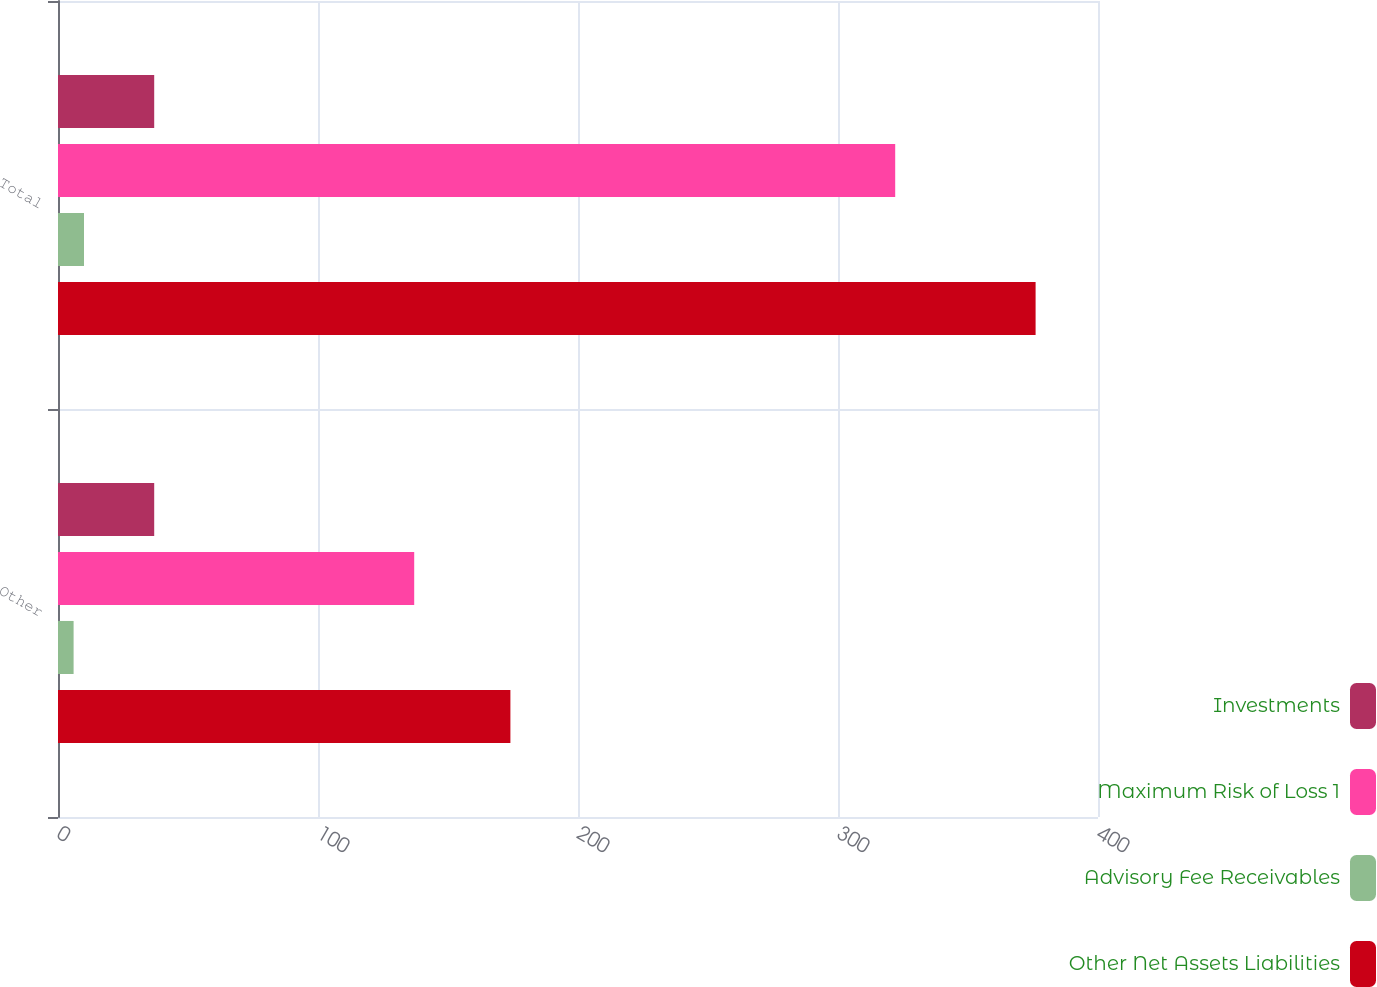Convert chart to OTSL. <chart><loc_0><loc_0><loc_500><loc_500><stacked_bar_chart><ecel><fcel>Other<fcel>Total<nl><fcel>Investments<fcel>37<fcel>37<nl><fcel>Maximum Risk of Loss 1<fcel>137<fcel>322<nl><fcel>Advisory Fee Receivables<fcel>6<fcel>10<nl><fcel>Other Net Assets Liabilities<fcel>174<fcel>376<nl></chart> 